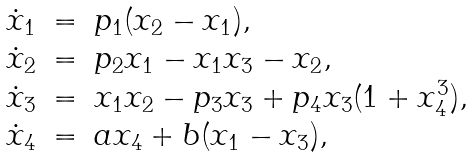Convert formula to latex. <formula><loc_0><loc_0><loc_500><loc_500>\begin{array} { l l l } \dot { x } _ { 1 } & = & p _ { 1 } ( x _ { 2 } - x _ { 1 } ) , \\ \dot { x } _ { 2 } & = & p _ { 2 } x _ { 1 } - x _ { 1 } x _ { 3 } - x _ { 2 } , \\ \dot { x } _ { 3 } & = & x _ { 1 } x _ { 2 } - p _ { 3 } x _ { 3 } + p _ { 4 } x _ { 3 } ( 1 + x ^ { 3 } _ { 4 } ) , \\ \dot { x } _ { 4 } & = & a x _ { 4 } + b ( x _ { 1 } - x _ { 3 } ) , \end{array}</formula> 